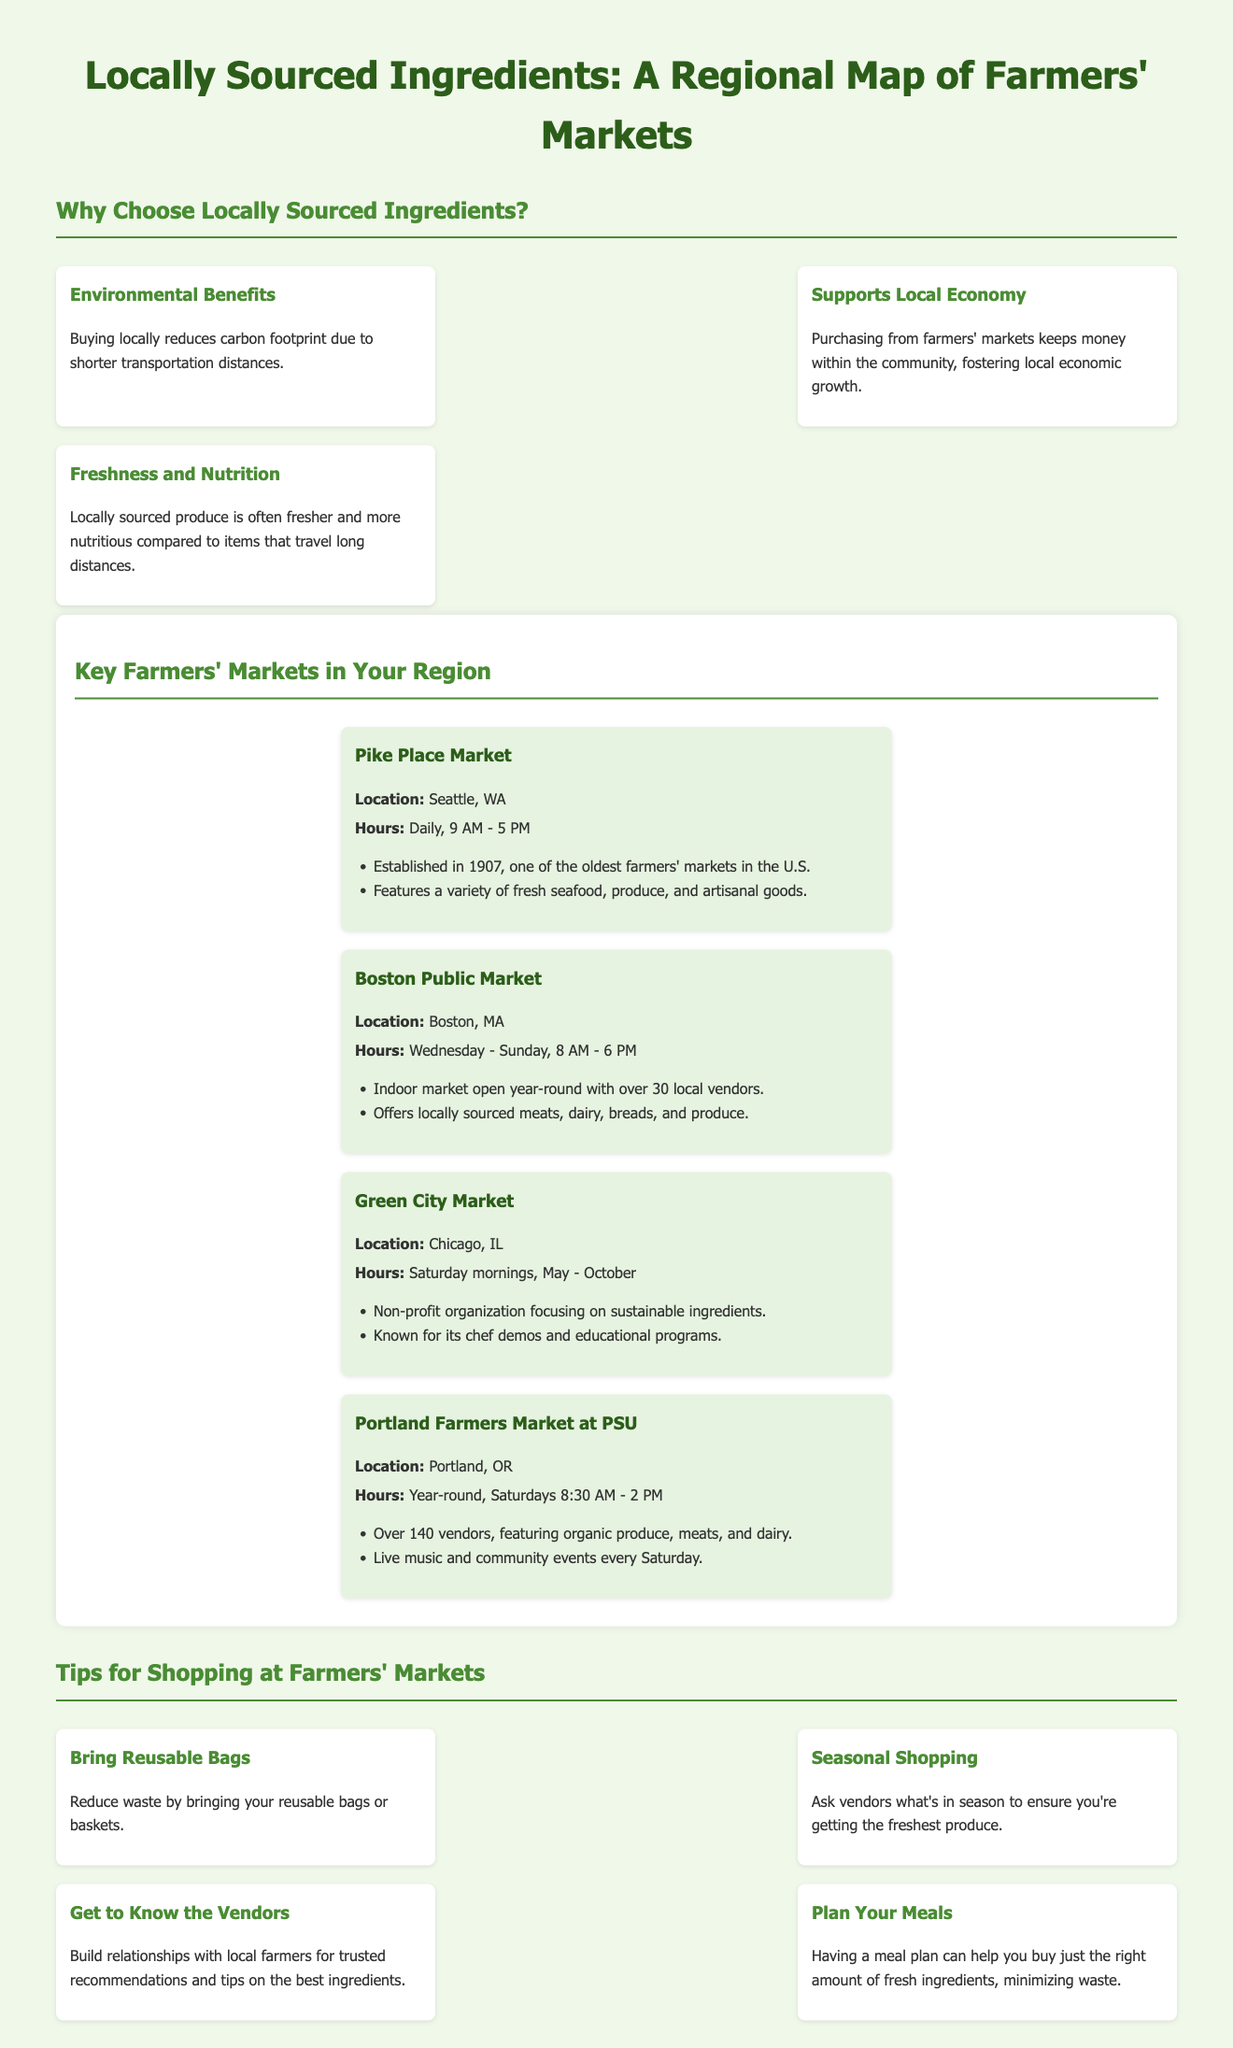What is the title of the infographic? The title of the infographic is displayed prominently at the top of the document.
Answer: Locally Sourced Ingredients: A Regional Map of Farmers' Markets What is the location of Pike Place Market? The location for Pike Place Market is mentioned under its name in the document.
Answer: Seattle, WA How many vendors are featured at Portland Farmers Market at PSU? The number of vendors is noted in the description of the market.
Answer: Over 140 vendors What day does the Green City Market occur? The days are specified in the hours section for Green City Market.
Answer: Saturday mornings What is one benefit of buying locally? The document provides several benefits and one is specified under Environmental Benefits.
Answer: Reduces carbon footprint Which farmers' market is open year-round? The document states the operating schedule of each market, highlighting any that are open year-round.
Answer: Portland Farmers Market at PSU What should you bring to reduce waste while shopping? The tips section advises on packing for shopping at farmers' markets.
Answer: Reusable bags What is a recommended shopping tip for getting fresh produce? The tips section offers strategies for effective shopping at farmers' markets.
Answer: Ask vendors what's in season What year was Pike Place Market established? The establishment year is shared in the description of Pike Place Market.
Answer: 1907 